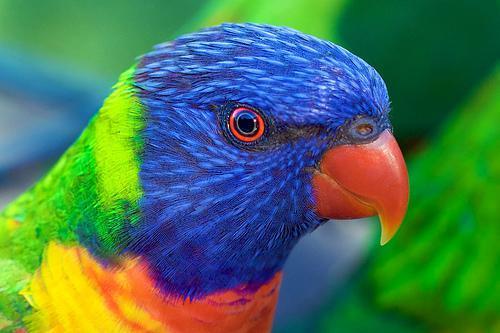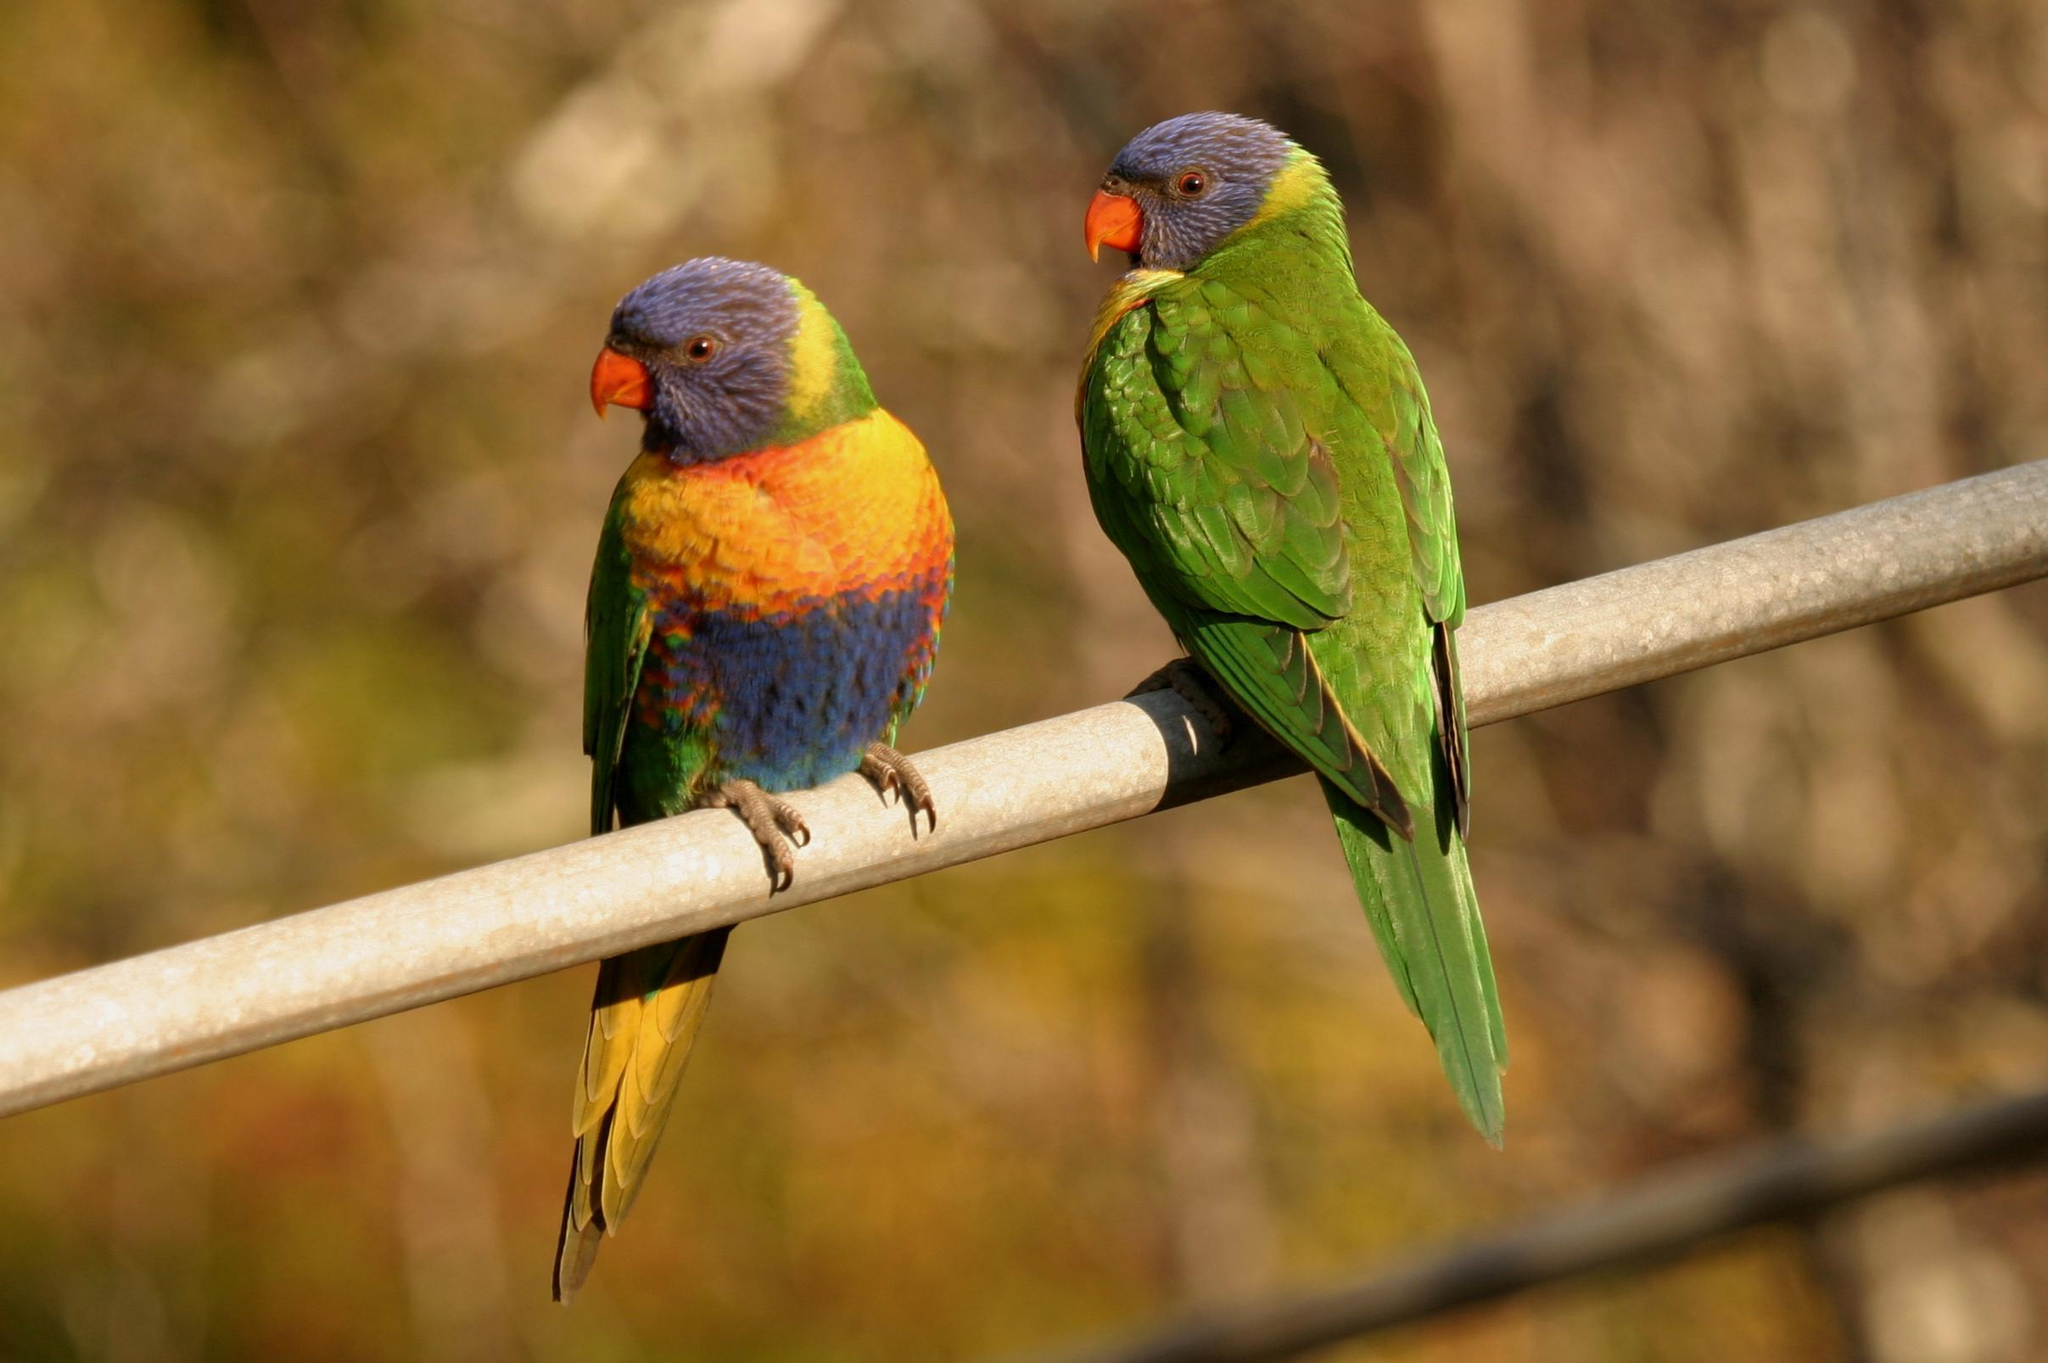The first image is the image on the left, the second image is the image on the right. Assess this claim about the two images: "There are exactly two parrots perched on a branch in the right image.". Correct or not? Answer yes or no. Yes. The first image is the image on the left, the second image is the image on the right. For the images shown, is this caption "The right hand image shows exactly two birds perched on the same branch and looking the same direction." true? Answer yes or no. Yes. 